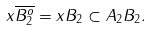<formula> <loc_0><loc_0><loc_500><loc_500>x \overline { B _ { 2 } ^ { o } } = x B _ { 2 } \subset A _ { 2 } B _ { 2 } .</formula> 